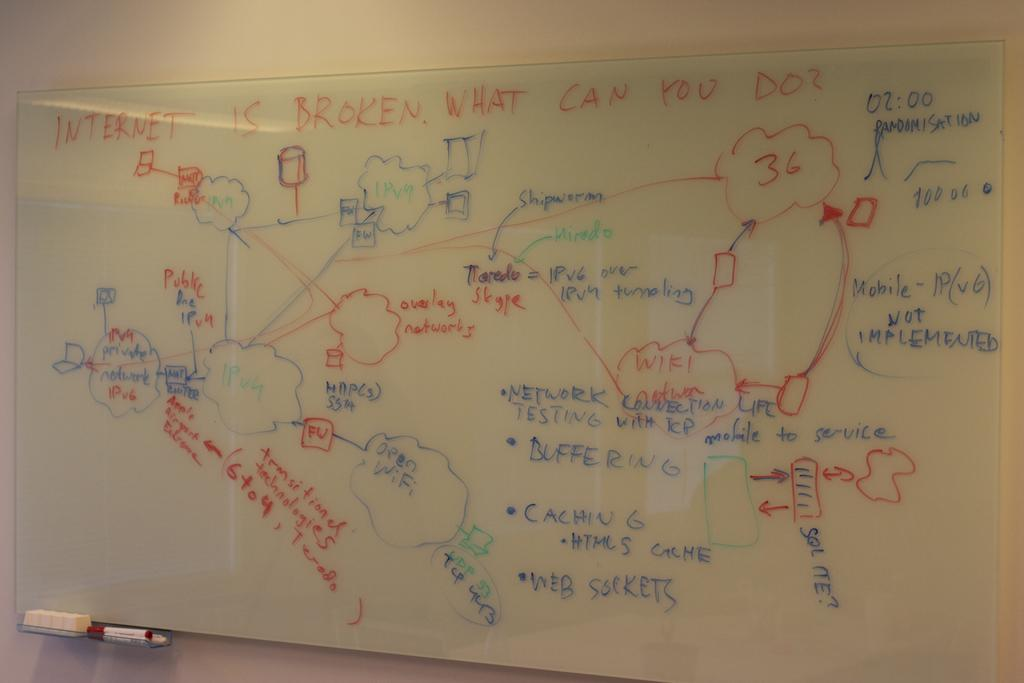<image>
Give a short and clear explanation of the subsequent image. a diagram on a white board titled 'internet is broken, what can you do?' 